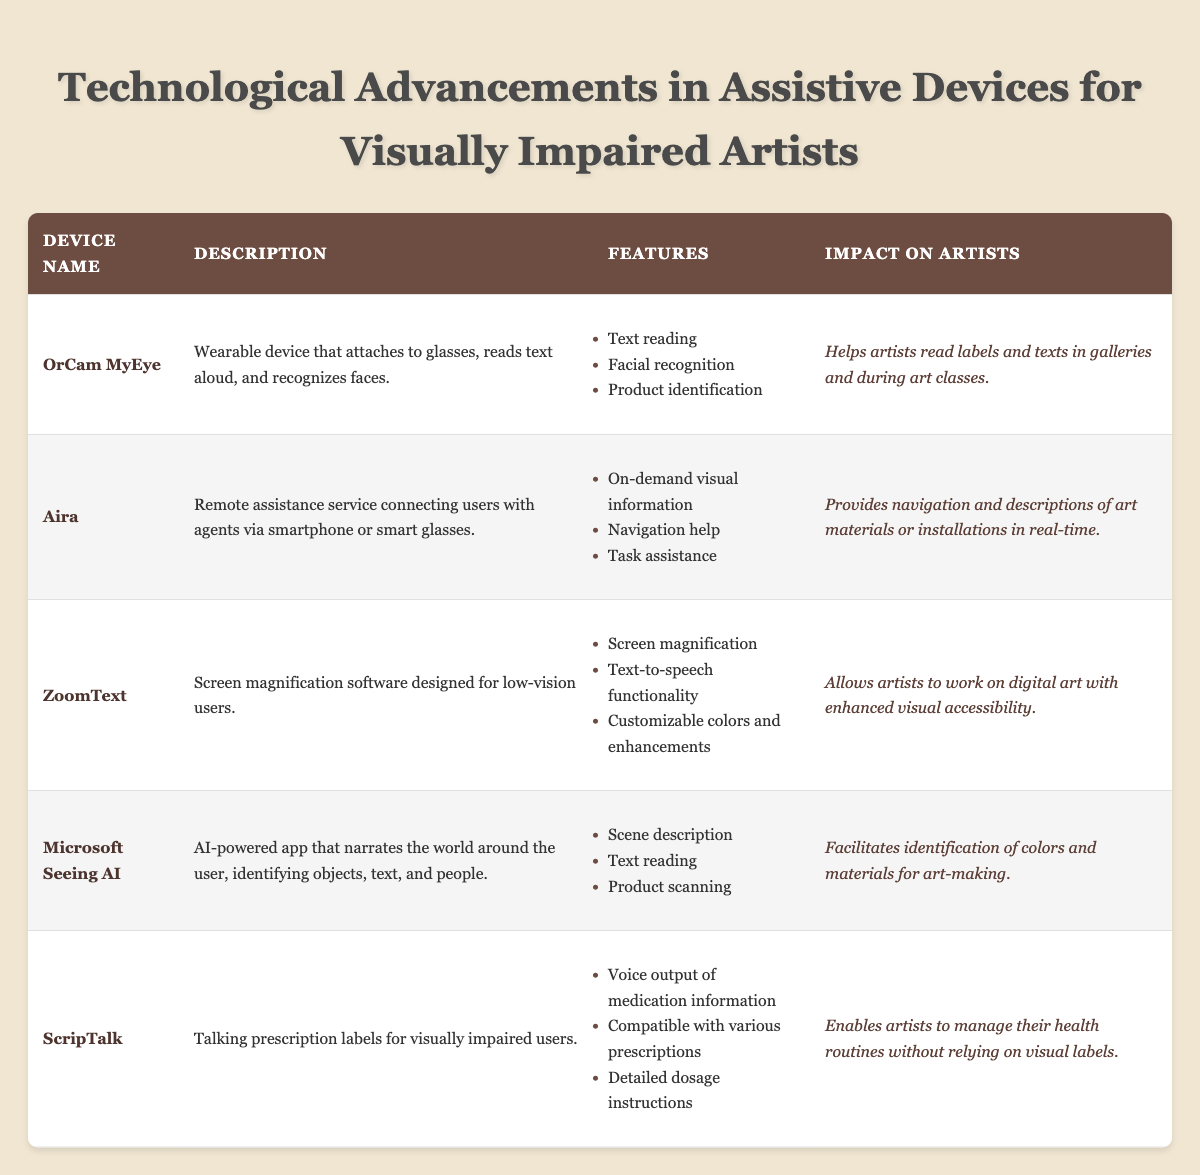What is the impact of the OrCam MyEye on artists? The table states that the OrCam MyEye helps artists read labels and texts in galleries and during art classes. This summarizes the specific ways in which the device is beneficial to artists.
Answer: It helps artists read labels and texts in galleries and during art classes How many assistive devices listed improve navigation for artists? From the table, only the Aira device specifically mentions providing navigation help. Counting the devices results in one assistive device that improves navigation for artists.
Answer: One Does ZoomText offer customization options? The table lists customizable colors and enhancements as part of ZoomText's features, which indicates that it does offer customization options.
Answer: Yes What are the key features of Microsoft Seeing AI? The key features of Microsoft Seeing AI listed in the table include scene description, text reading, and product scanning. These features enable a wide range of functionalities useful for artists.
Answer: Scene description, text reading, product scanning Which device helps visually impaired artists manage their health routines? The ScripTalk device is designed for this purpose, as its impact on artists specifies that it enables artists to manage their health routines without relying on visual labels.
Answer: ScripTalk How many devices provide text reading capabilities? Both OrCam MyEye, ZoomText, and Microsoft Seeing AI have text reading listed among their features. Therefore, we can count three devices that provide text reading capabilities.
Answer: Three If an artist primarily needs help in identifying colors for art-making, which device should they choose? Microsoft Seeing AI specifically facilitates the identification of colors and materials for art-making, making it the best choice for an artist with that specific need.
Answer: Microsoft Seeing AI Are there any devices listed that can assist artists while using digital art software? Yes, ZoomText, as indicated in the table, allows artists to work on digital art with enhanced visual accessibility, effectively assisting in that context.
Answer: Yes What unique feature does Aira provide that other devices do not? Aira uniquely provides on-demand visual information services that connect users with agents via smart technology, a feature not explicitly mentioned for the other listed devices.
Answer: On-demand visual information 